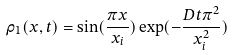Convert formula to latex. <formula><loc_0><loc_0><loc_500><loc_500>\rho _ { 1 } ( x , t ) = \sin ( \frac { \pi x } { x _ { i } } ) \exp ( - \frac { D t \pi ^ { 2 } } { x _ { i } ^ { 2 } } )</formula> 